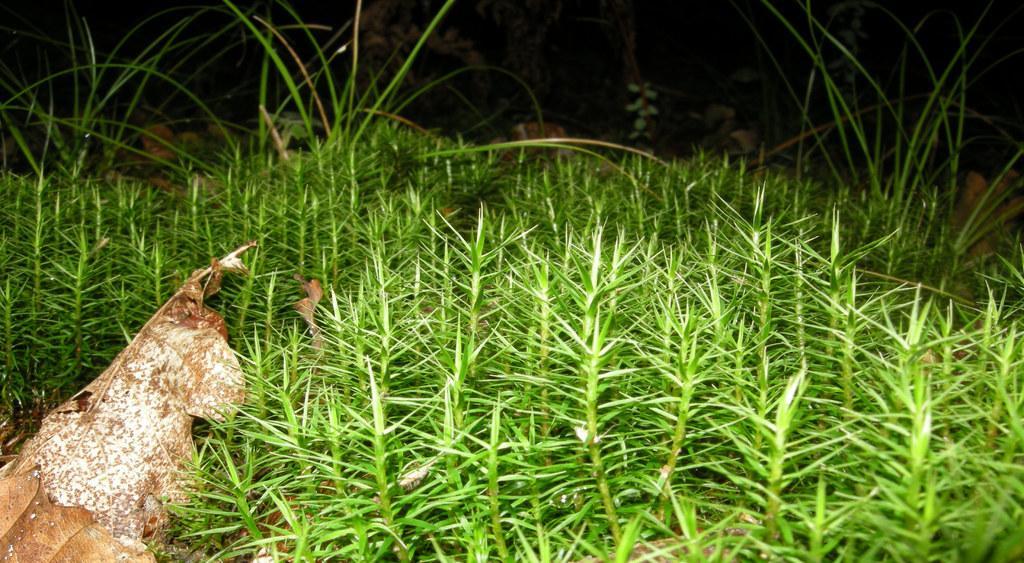In one or two sentences, can you explain what this image depicts? In this image, we can see some grass, plants. We can also see some dried leaves and rocks. We can also see the dark background. 